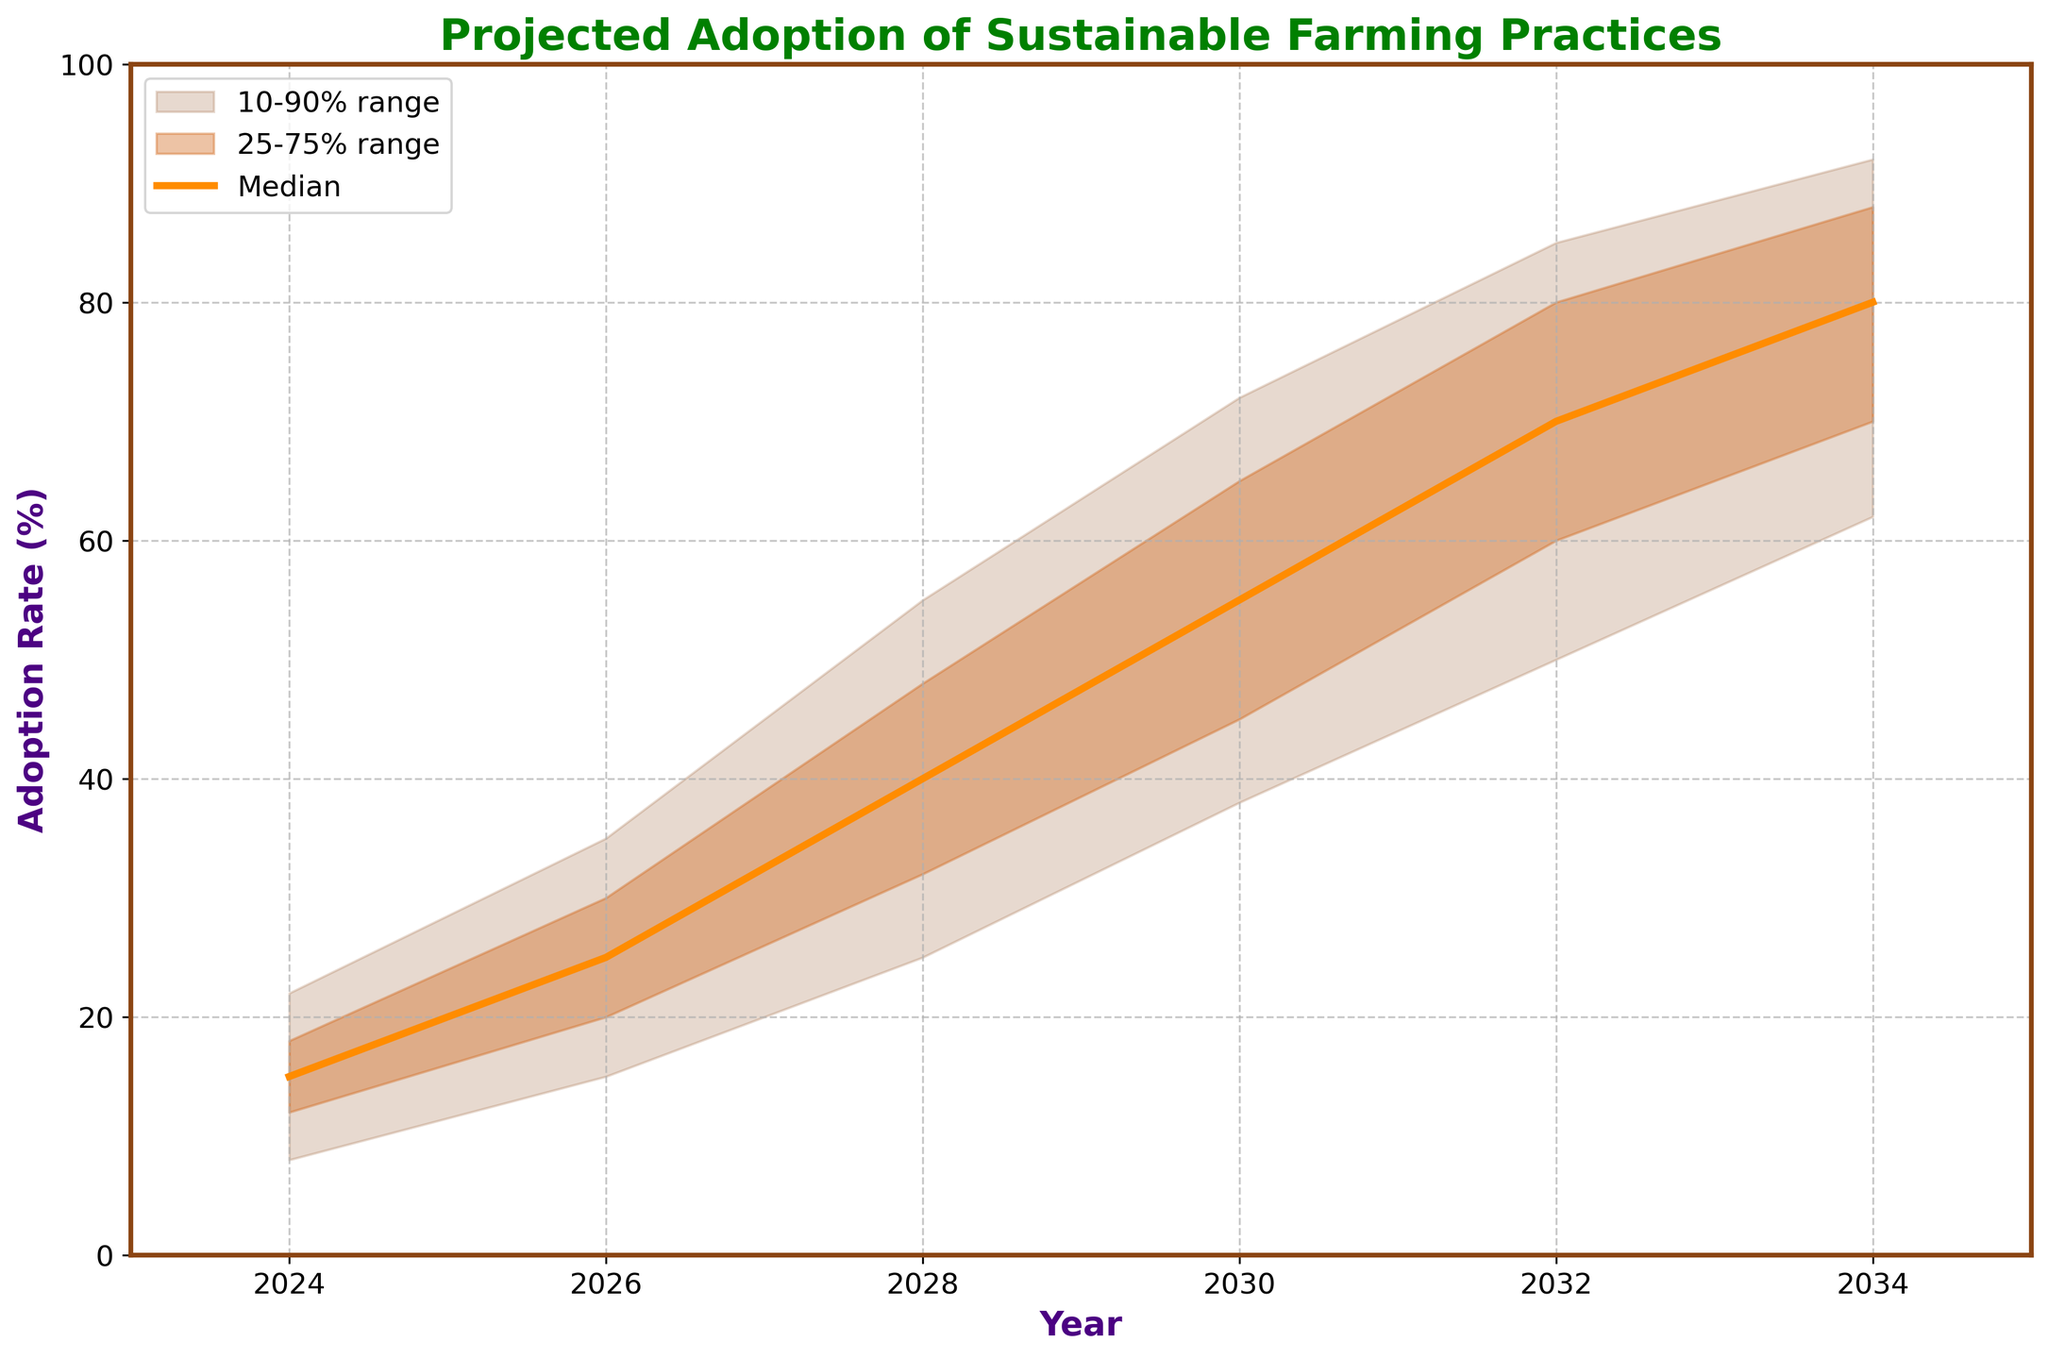what is the title of the chart? The title of the chart is displayed prominently at the top of the figure in bold text. It provides a summary of the data being presented.
Answer: Projected Adoption of Sustainable Farming Practices What is the median projected adoption rate for the year 2028? The chart has a distinct line representing the median with numerical values on the y-axis corresponding to adoption rates. Look at the year 2028 on the x-axis and find the corresponding median value.
Answer: 40% What does the shaded area between the lower 10% and upper 90% represent? This shaded area indicates the range within which the adoption rates are expected to fall 80% of the time, showing uncertainty and variability in projections.
Answer: 10-90% range How does the adoption rate change from 2024 to 2030 on average? To find the average change, first note the adoption rates for 2024 (15%) and 2030 (55%). Then, calculate the difference and divide it by the number of years from 2024 to 2030, which is 6 years.
Answer: Approximately 6.67% per year During which year is the difference between the lower 25% and upper 75% range the most significant? Calculate the difference between the upper 75% and lower 25% for each year and determine the year with the maximum difference.
Answer: 2028 By how much does the median adoption rate increase from 2026 to 2032? Look at the median values for the years 2026 (25%) and 2032 (70%). Subtract the former from the latter to find the increase.
Answer: 45% Which year shows the highest projected upper 90% adoption rate? Identify the highest value along the upper 90% shaded line and note the corresponding year on the x-axis.
Answer: 2034 What is the expected adoption rate range for the year 2026? The expected range is between the lower 10% (15%) and upper 90% (35%) projections for 2026.
Answer: 15%-35% How is the upper 75% projection in 2030 compared to the upper 75% projection in 2024? Read the upper 75% projection values for both years and compare them to determine if it has increased or decreased.
Answer: It increases (18% in 2024 to 65% in 2030) 